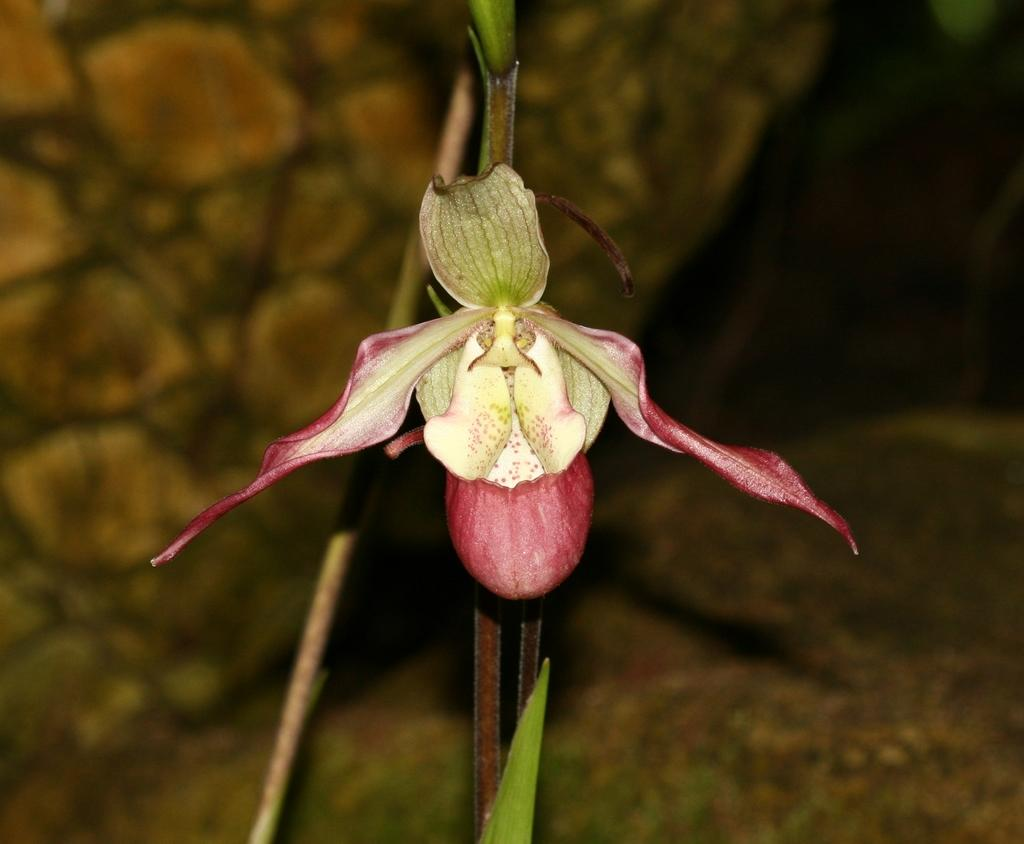What is the main subject of the image? There is a flower in the middle of the image. Can you describe the flower in more detail? Unfortunately, the image does not provide enough detail to describe the flower further. Is there anything else visible in the image besides the flower? The provided facts do not mention any other objects or subjects in the image. What type of engine is powering the flower in the image? There is no engine present in the image, as it features a flower and no other objects or subjects. 